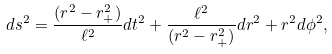Convert formula to latex. <formula><loc_0><loc_0><loc_500><loc_500>d s ^ { 2 } = \frac { ( r ^ { 2 } - r _ { + } ^ { 2 } ) } { \ell ^ { 2 } } d t ^ { 2 } + \frac { \ell ^ { 2 } } { ( r ^ { 2 } - r _ { + } ^ { 2 } ) } d r ^ { 2 } + r ^ { 2 } d \phi ^ { 2 } ,</formula> 